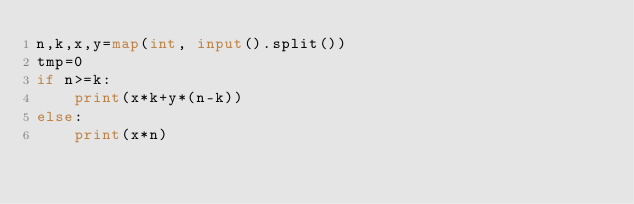<code> <loc_0><loc_0><loc_500><loc_500><_Python_>n,k,x,y=map(int, input().split())
tmp=0
if n>=k:
    print(x*k+y*(n-k))
else:
    print(x*n)
        </code> 